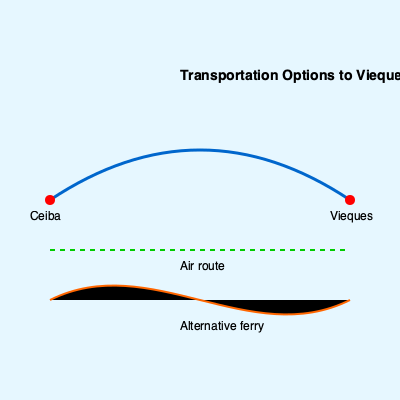Based on the map, which transportation option would likely be the most reliable for maintaining consistent access to Vieques during periods of ferry service disruptions? To determine the most reliable transportation option during ferry service disruptions, let's analyze the map:

1. The solid blue curved line represents the main ferry route between Ceiba and Vieques. This is the primary transportation method, but it's subject to disruptions.

2. The green dashed line represents an air route. Air transportation has several advantages:
   a) It's not affected by sea conditions that might disrupt ferry services.
   b) It's typically faster than ferry travel.
   c) It operates on a more consistent schedule.

3. The orange curved line represents an alternative ferry route. While this could provide another option, it may face similar challenges as the main ferry route, such as:
   a) Susceptibility to weather conditions.
   b) Potential mechanical issues.
   c) Possible staffing or operational problems.

4. Considering the need for consistent access, especially during periods of main ferry service disruptions, the air route emerges as the most reliable option. It's less affected by the factors that typically cause ferry disruptions and can maintain a more regular schedule.

Therefore, the air route would likely be the most reliable for maintaining consistent access to Vieques during periods of ferry service disruptions.
Answer: Air route 